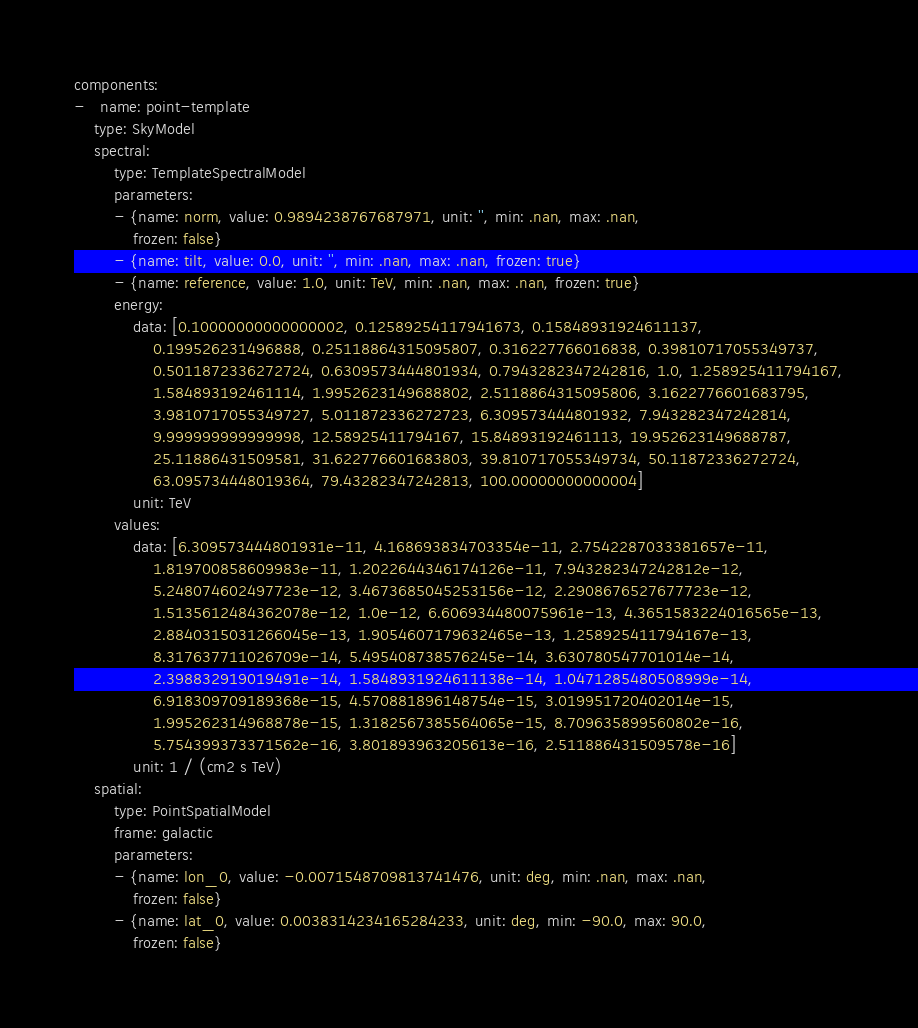<code> <loc_0><loc_0><loc_500><loc_500><_YAML_>components:
-   name: point-template
    type: SkyModel
    spectral:
        type: TemplateSpectralModel
        parameters:
        - {name: norm, value: 0.9894238767687971, unit: '', min: .nan, max: .nan,
            frozen: false}
        - {name: tilt, value: 0.0, unit: '', min: .nan, max: .nan, frozen: true}
        - {name: reference, value: 1.0, unit: TeV, min: .nan, max: .nan, frozen: true}
        energy:
            data: [0.10000000000000002, 0.12589254117941673, 0.15848931924611137,
                0.199526231496888, 0.25118864315095807, 0.316227766016838, 0.39810717055349737,
                0.5011872336272724, 0.6309573444801934, 0.7943282347242816, 1.0, 1.258925411794167,
                1.584893192461114, 1.9952623149688802, 2.5118864315095806, 3.1622776601683795,
                3.9810717055349727, 5.011872336272723, 6.309573444801932, 7.943282347242814,
                9.999999999999998, 12.58925411794167, 15.84893192461113, 19.952623149688787,
                25.11886431509581, 31.622776601683803, 39.810717055349734, 50.11872336272724,
                63.095734448019364, 79.43282347242813, 100.00000000000004]
            unit: TeV
        values:
            data: [6.309573444801931e-11, 4.168693834703354e-11, 2.7542287033381657e-11,
                1.819700858609983e-11, 1.2022644346174126e-11, 7.943282347242812e-12,
                5.248074602497723e-12, 3.4673685045253156e-12, 2.2908676527677723e-12,
                1.5135612484362078e-12, 1.0e-12, 6.606934480075961e-13, 4.3651583224016565e-13,
                2.8840315031266045e-13, 1.9054607179632465e-13, 1.258925411794167e-13,
                8.317637711026709e-14, 5.495408738576245e-14, 3.630780547701014e-14,
                2.398832919019491e-14, 1.5848931924611138e-14, 1.0471285480508999e-14,
                6.918309709189368e-15, 4.570881896148754e-15, 3.019951720402014e-15,
                1.995262314968878e-15, 1.3182567385564065e-15, 8.709635899560802e-16,
                5.754399373371562e-16, 3.801893963205613e-16, 2.511886431509578e-16]
            unit: 1 / (cm2 s TeV)
    spatial:
        type: PointSpatialModel
        frame: galactic
        parameters:
        - {name: lon_0, value: -0.0071548709813741476, unit: deg, min: .nan, max: .nan,
            frozen: false}
        - {name: lat_0, value: 0.0038314234165284233, unit: deg, min: -90.0, max: 90.0,
            frozen: false}
</code> 